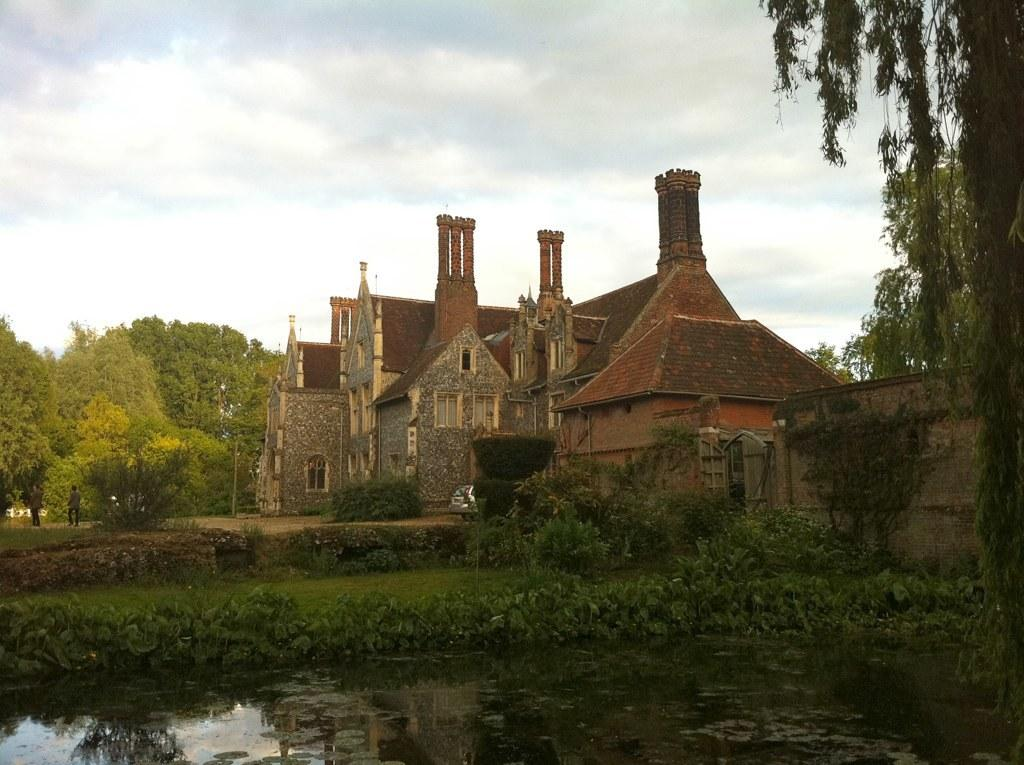What type of structures can be seen in the image? There are buildings in the image. What feature can be observed on the buildings? There are windows visible in the image. What type of vegetation is present in the image? There are trees in the image. What architectural element is visible in the image? There is a wall in the image. Who or what is present in the image? There are people in the image. What natural element can be seen in the image? There is water visible in the image. What is the color of the sky in the image? The sky is blue and white in color. Can you hear the kitten coughing in the image? There is no kitten or any sound present in the image, as it is a still image. 